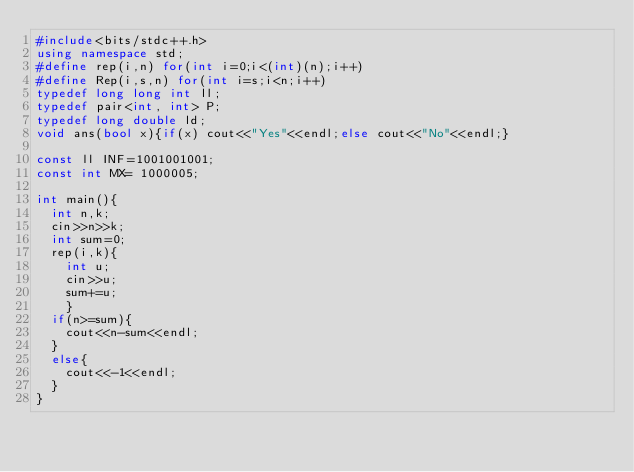Convert code to text. <code><loc_0><loc_0><loc_500><loc_500><_C++_>#include<bits/stdc++.h>
using namespace std;
#define rep(i,n) for(int i=0;i<(int)(n);i++)
#define Rep(i,s,n) for(int i=s;i<n;i++)
typedef long long int ll;
typedef pair<int, int> P;
typedef long double ld;
void ans(bool x){if(x) cout<<"Yes"<<endl;else cout<<"No"<<endl;}

const ll INF=1001001001;
const int MX= 1000005;

int main(){
  int n,k;
  cin>>n>>k;
  int sum=0;
  rep(i,k){
    int u;
    cin>>u;
    sum+=u;
    }
  if(n>=sum){
    cout<<n-sum<<endl;
  }
  else{
    cout<<-1<<endl;
  }
}</code> 